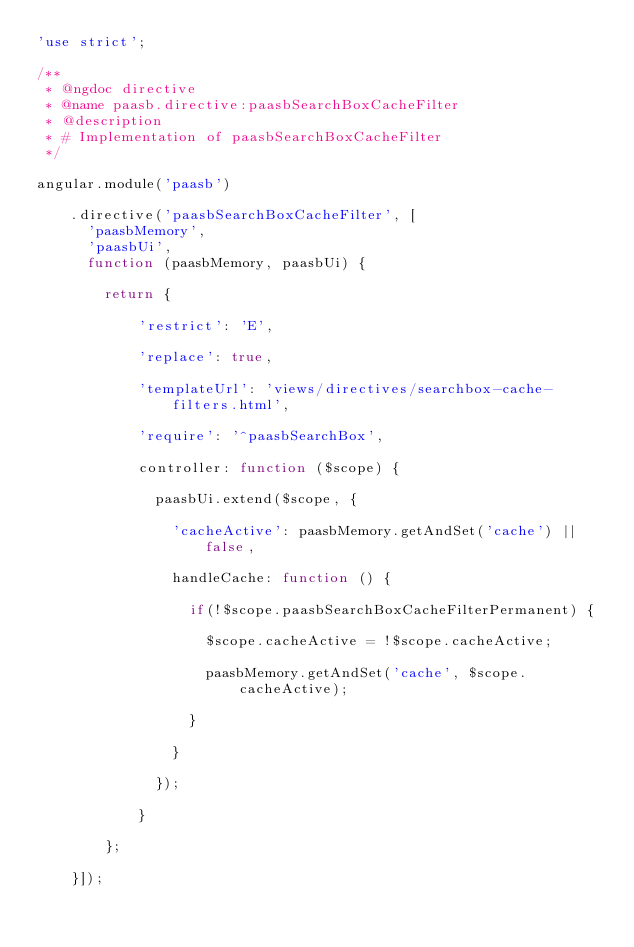Convert code to text. <code><loc_0><loc_0><loc_500><loc_500><_JavaScript_>'use strict';

/**
 * @ngdoc directive
 * @name paasb.directive:paasbSearchBoxCacheFilter
 * @description
 * # Implementation of paasbSearchBoxCacheFilter
 */

angular.module('paasb')

    .directive('paasbSearchBoxCacheFilter', [
      'paasbMemory',
      'paasbUi',
      function (paasbMemory, paasbUi) {

        return {

            'restrict': 'E',

            'replace': true,

            'templateUrl': 'views/directives/searchbox-cache-filters.html',

            'require': '^paasbSearchBox',

            controller: function ($scope) {

              paasbUi.extend($scope, {

                'cacheActive': paasbMemory.getAndSet('cache') || false,

                handleCache: function () {

                  if(!$scope.paasbSearchBoxCacheFilterPermanent) {

                    $scope.cacheActive = !$scope.cacheActive;

                    paasbMemory.getAndSet('cache', $scope.cacheActive);

                  }

                }

              });

            }

        };

    }]);
</code> 